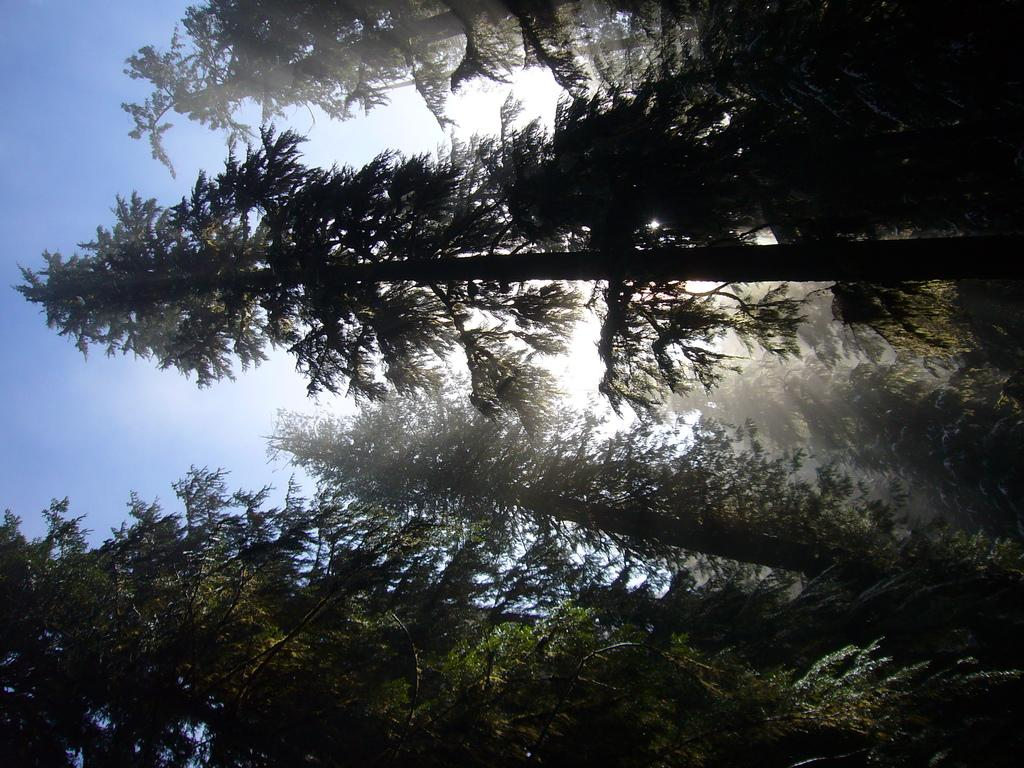What type of vegetation is present in the image? There are tall trees in the image. What can be seen in the background of the image? There is a sky visible in the background of the image. What is the condition of the sky in the image? There are clouds in the sky. Can you see the tail of the whale in the image? There is no whale or tail present in the image; it features tall trees and a sky with clouds. 